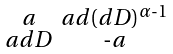Convert formula to latex. <formula><loc_0><loc_0><loc_500><loc_500>\begin{smallmatrix} a & a d ( d D ) ^ { \alpha \text {-} 1 } \\ a d D & \text {-} a \end{smallmatrix}</formula> 